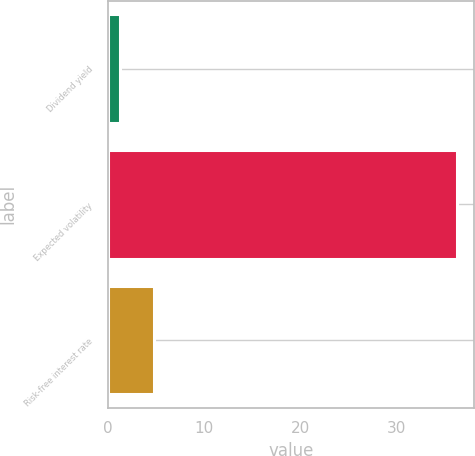Convert chart to OTSL. <chart><loc_0><loc_0><loc_500><loc_500><bar_chart><fcel>Dividend yield<fcel>Expected volatility<fcel>Risk-free interest rate<nl><fcel>1.27<fcel>36.2<fcel>4.76<nl></chart> 